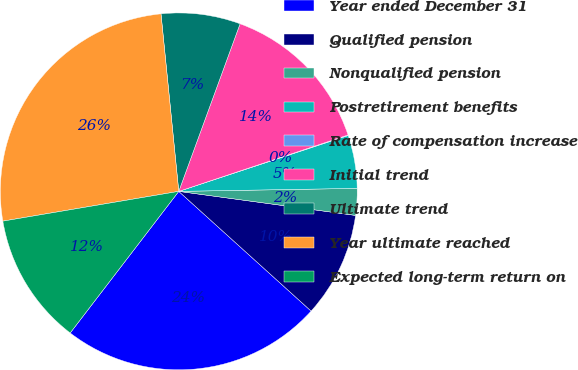<chart> <loc_0><loc_0><loc_500><loc_500><pie_chart><fcel>Year ended December 31<fcel>Qualified pension<fcel>Nonqualified pension<fcel>Postretirement benefits<fcel>Rate of compensation increase<fcel>Initial trend<fcel>Ultimate trend<fcel>Year ultimate reached<fcel>Expected long-term return on<nl><fcel>23.71%<fcel>9.55%<fcel>2.42%<fcel>4.8%<fcel>0.05%<fcel>14.3%<fcel>7.17%<fcel>26.08%<fcel>11.92%<nl></chart> 